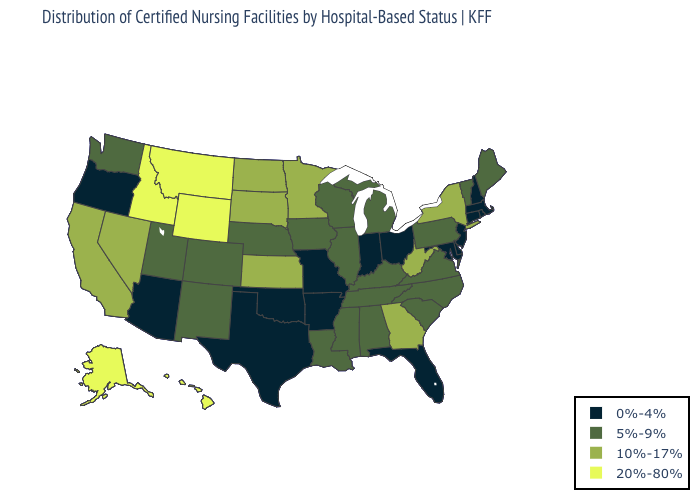Name the states that have a value in the range 10%-17%?
Concise answer only. California, Georgia, Kansas, Minnesota, Nevada, New York, North Dakota, South Dakota, West Virginia. How many symbols are there in the legend?
Answer briefly. 4. What is the value of Minnesota?
Be succinct. 10%-17%. Does Connecticut have the same value as Oklahoma?
Give a very brief answer. Yes. Which states hav the highest value in the South?
Be succinct. Georgia, West Virginia. Which states have the lowest value in the USA?
Quick response, please. Arizona, Arkansas, Connecticut, Delaware, Florida, Indiana, Maryland, Massachusetts, Missouri, New Hampshire, New Jersey, Ohio, Oklahoma, Oregon, Rhode Island, Texas. What is the value of North Dakota?
Write a very short answer. 10%-17%. What is the value of Kentucky?
Be succinct. 5%-9%. Does Montana have the highest value in the West?
Keep it brief. Yes. Which states have the lowest value in the South?
Answer briefly. Arkansas, Delaware, Florida, Maryland, Oklahoma, Texas. Among the states that border Colorado , which have the highest value?
Be succinct. Wyoming. What is the highest value in the USA?
Concise answer only. 20%-80%. Does Illinois have the highest value in the MidWest?
Short answer required. No. 